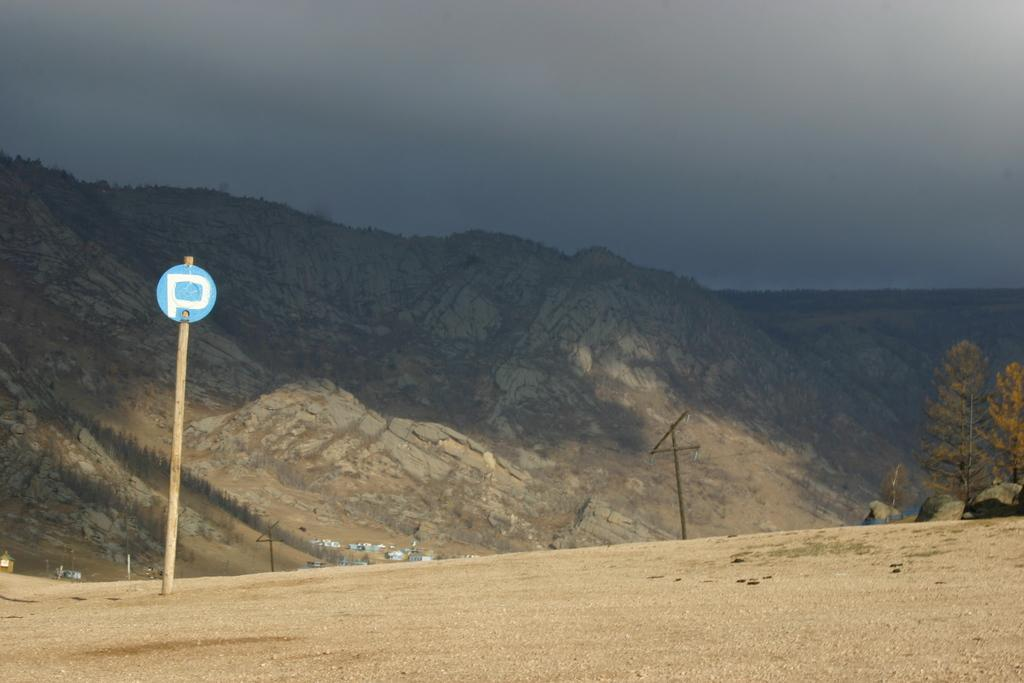What type of terrain is featured in the image? There is a hill surface in the image. What is attached to the pole on the hill surface? There is a board attached to the pole on the hill surface. What type of vegetation can be seen in the image? There are trees visible in the image. What can be seen in the background of the image? There are rocky hills and the sky visible in the background of the image. What is the reaction of the trees to the attack in the image? There is no attack or reaction from the trees in the image; it features a hill surface, a pole with a board, trees, and a background with rocky hills and the sky. 